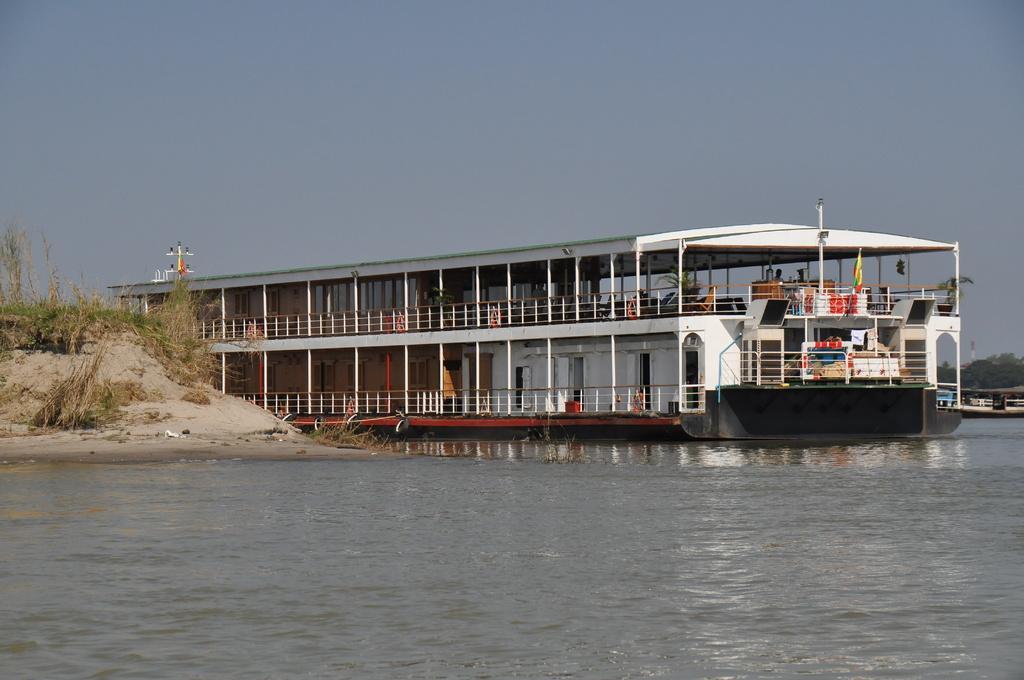Please provide a concise description of this image. In this image in the middle, there is a boat, in side that there are some people, flags, doors, poles. At the bottom there are waves and water. On the right there are boats, trees and sky. On the left there are plants and land. 